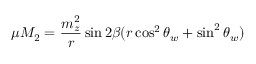Convert formula to latex. <formula><loc_0><loc_0><loc_500><loc_500>\mu M _ { 2 } = \frac { m _ { z } ^ { 2 } } { r } \sin 2 \beta ( r \cos ^ { 2 } \theta _ { w } + \sin ^ { 2 } \theta _ { w } )</formula> 